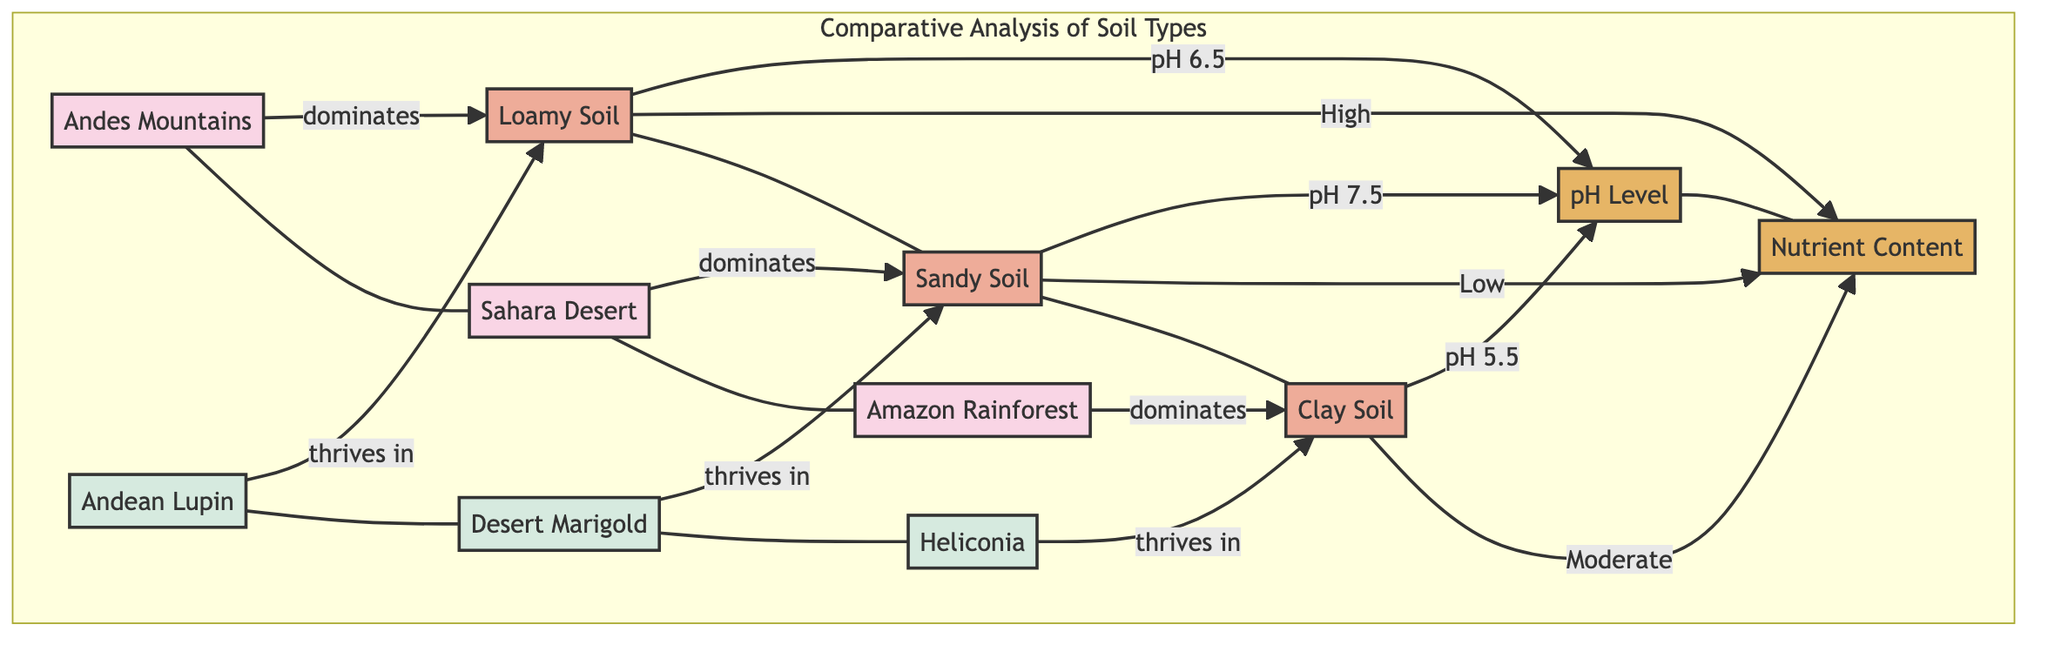What is the dominant soil type in the Andes Mountains? The diagram indicates that the Andes Mountains region is associated with loamy soil, shown as the dominant soil type.
Answer: Loamy Soil What is the pH level of the soil in the Sahara Desert? The diagram states that the sandy soil in the Sahara Desert has a pH level of 7.5.
Answer: pH 7.5 Which flower thrives in the Amazon Rainforest? According to the diagram, the flower species that thrives in the Amazon Rainforest is Heliconia.
Answer: Heliconia What is the nutrient content of loamy soil? The diagram specifies that loamy soil has high nutrient content, correlating to its favorable characteristics for plant growth.
Answer: High Which region has clay soil? The diagram identifies the Amazon Rainforest as the region dominated by clay soil.
Answer: Amazon Rainforest What is the relationship between loamy soil and Andean Lupin? The diagram illustrates that Andean Lupin thrives in loamy soil, indicating a successful growth correlation between the two.
Answer: Thrives in What soil characteristic is associated with sandy soil? The diagram notes that sandy soil has low nutrient content, which is an important characteristic affecting the growth of plants in that soil type.
Answer: Low How many soil types are represented in the diagram? The diagram displays three different soil types: loamy soil, sandy soil, and clay soil, indicating the variety across the regions.
Answer: Three Explain the reason why Heliconia thrives in its corresponding soil type. Heliconia thrives in clay soil, which has a pH of 5.5 and moderate nutrient content; these characteristics are conducive to its successful growth according to the diagram.
Answer: Clay Soil, pH 5.5, Moderate What is the nutrient content of the soil where the Desert Marigold grows? The diagram states that sandy soil, where Desert Marigold grows, has low nutrient content, which is a key factor in determining plant growth success in that region.
Answer: Low 